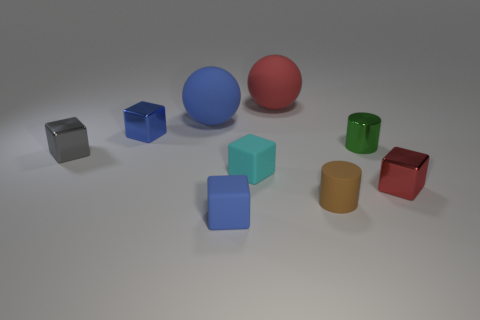Subtract all red cubes. How many cubes are left? 4 Subtract all cyan cubes. How many cubes are left? 4 Subtract all purple blocks. Subtract all purple spheres. How many blocks are left? 5 Add 1 tiny cyan blocks. How many objects exist? 10 Subtract all cylinders. How many objects are left? 7 Add 3 small green metallic cylinders. How many small green metallic cylinders are left? 4 Add 4 tiny matte cylinders. How many tiny matte cylinders exist? 5 Subtract 0 yellow balls. How many objects are left? 9 Subtract all small red shiny blocks. Subtract all small cyan rubber spheres. How many objects are left? 8 